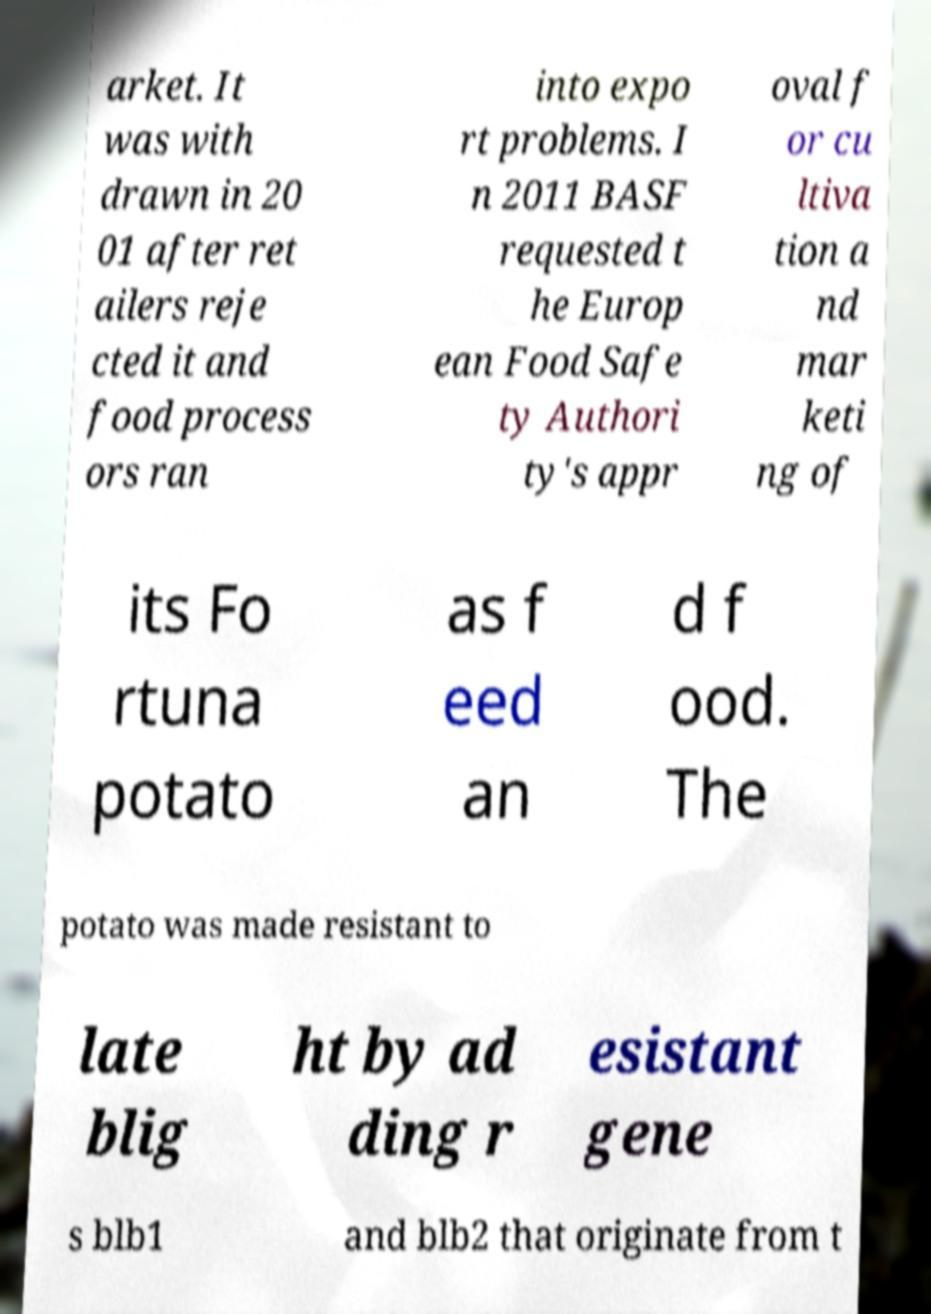Please read and relay the text visible in this image. What does it say? arket. It was with drawn in 20 01 after ret ailers reje cted it and food process ors ran into expo rt problems. I n 2011 BASF requested t he Europ ean Food Safe ty Authori ty's appr oval f or cu ltiva tion a nd mar keti ng of its Fo rtuna potato as f eed an d f ood. The potato was made resistant to late blig ht by ad ding r esistant gene s blb1 and blb2 that originate from t 